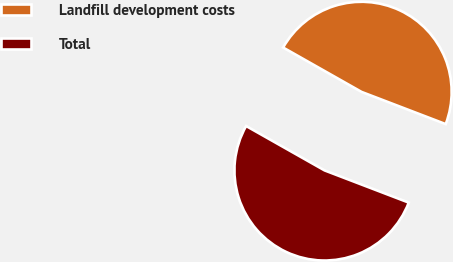Convert chart to OTSL. <chart><loc_0><loc_0><loc_500><loc_500><pie_chart><fcel>Landfill development costs<fcel>Total<nl><fcel>47.62%<fcel>52.38%<nl></chart> 